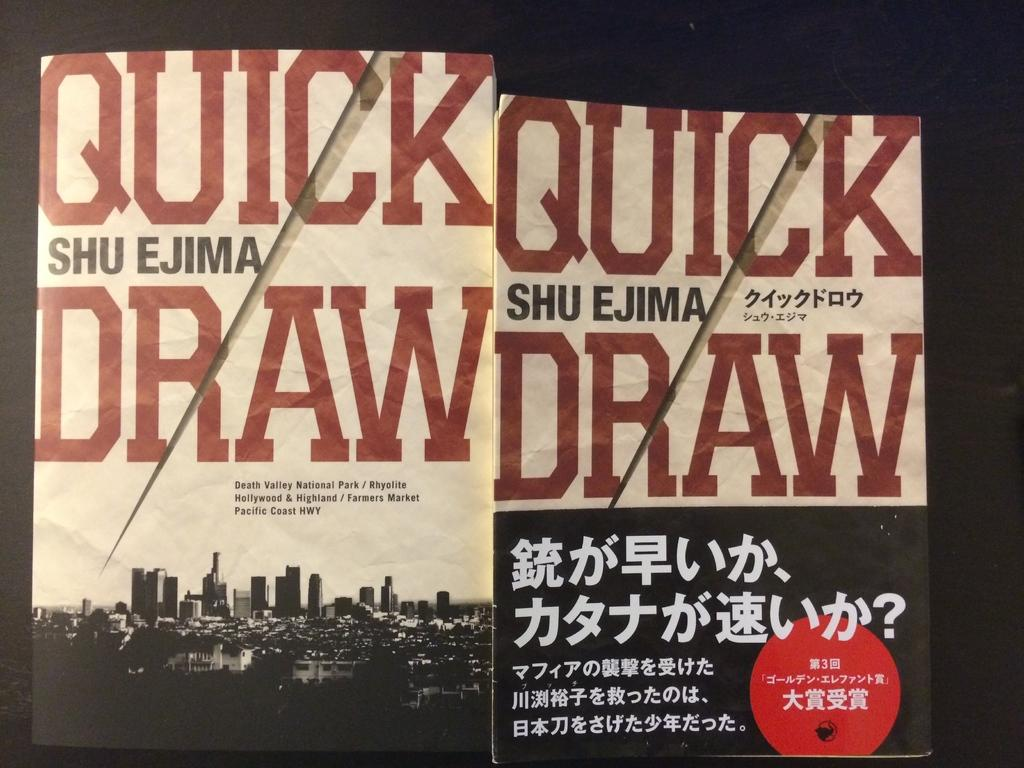<image>
Give a short and clear explanation of the subsequent image. The book is titles Quick Draw written by Shu Ejima 